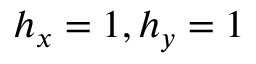<formula> <loc_0><loc_0><loc_500><loc_500>h _ { x } = 1 , h _ { y } = 1</formula> 